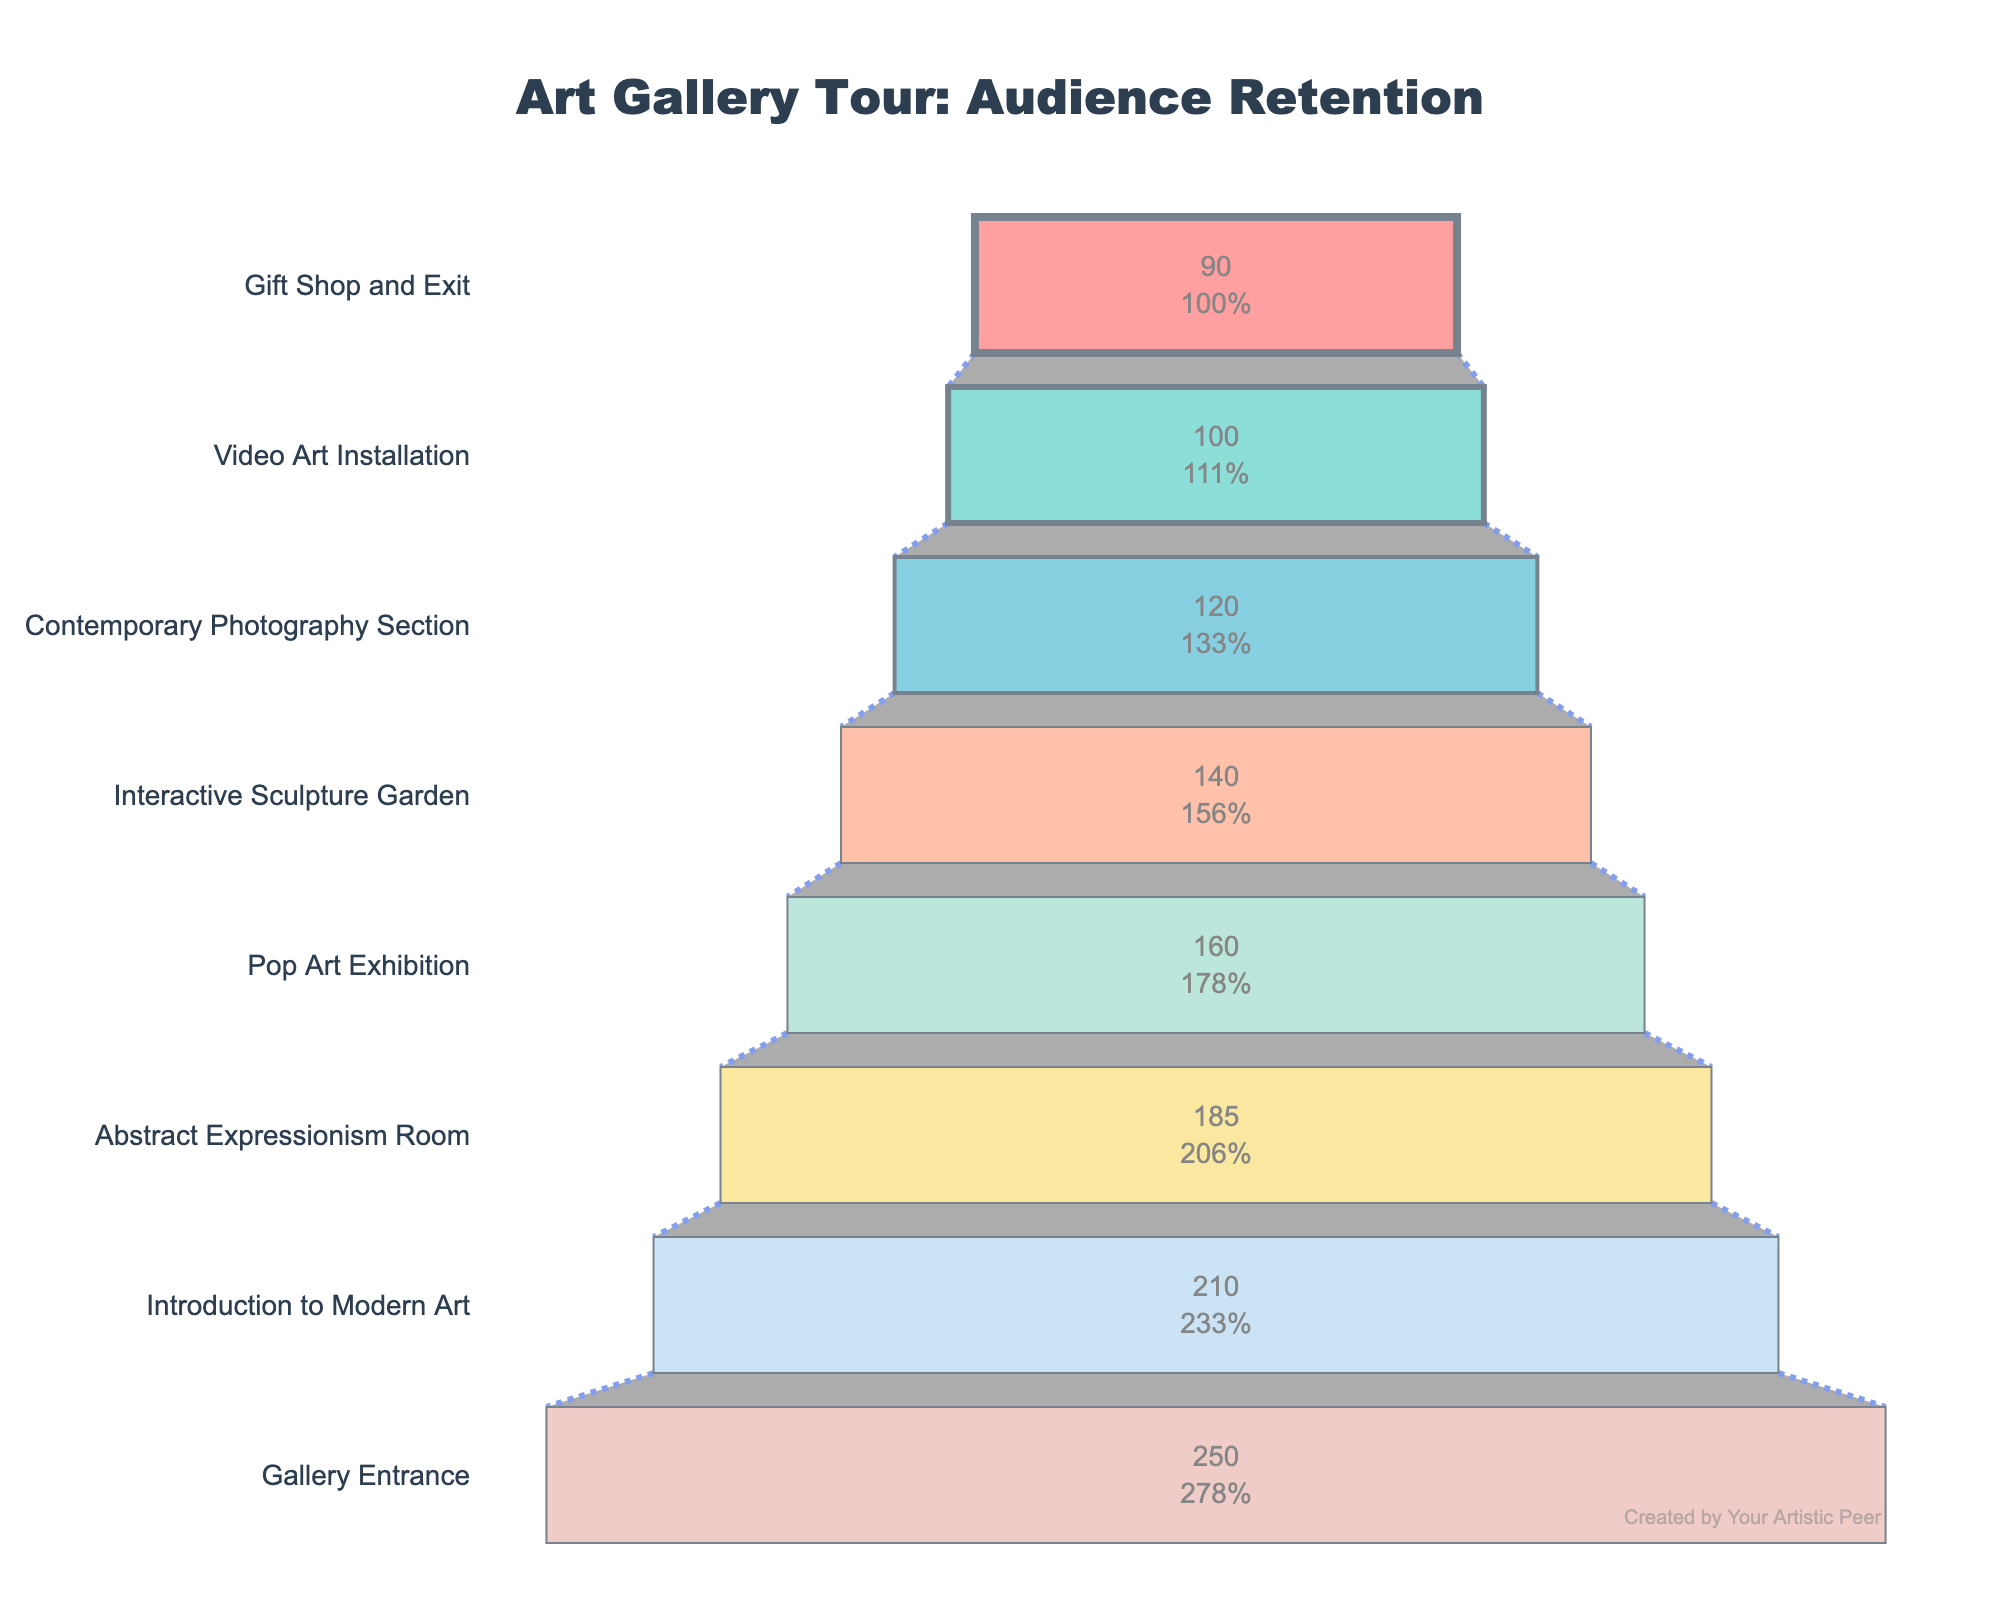what is the title of the chart? The title is prominently displayed at the top of the chart, which reads "Art Gallery Tour: Audience Retention".
Answer: Art Gallery Tour: Audience Retention Which segment had the highest number of visitors? The segment with the highest number of visitors is displayed at the top of the funnel, indicating the initial point of measurement.
Answer: Gallery Entrance What is the total drop-off in visitors from the entrance to the exit? We need to subtract the number of visitors at the "Gift Shop and Exit" segment from the "Gallery Entrance" segment. Hence, 250 (Entrance) - 90 (Exit) = 160.
Answer: 160 How many segments have fewer than 150 visitors? Examine each segment to determine if the number of visitors is less than 150. The segments with fewer than 150 visitors are "Contemporary Photography Section", "Video Art Installation", and "Gift Shop and Exit", totaling 3 segments.
Answer: 3 Which segment has the greatest retention from the previous segment in terms of raw numbers? By comparing the differences between consecutive segments, "Introduction to Modern Art" to "Abstract Expressionism Room" has the smallest drop-off of 25 visitors.
Answer: Abstract Expressionism Room What percentage of the initial visitors remained by the time they reached the "Video Art Installation"? Find the percentage by dividing visitors of "Video Art Installation" by "Gallery Entrance" and multiplying by 100. (100/250) * 100 = 40%
Answer: 40% Which segment had more visitors, the "Interactive Sculpture Garden" or the "Contemporary Photography Section"? Compare the number of visitors for each segment. The "Interactive Sculpture Garden" has 140 visitors, while the "Contemporary Photography Section" has 120. Hence, the "Interactive Sculpture Garden" had more visitors.
Answer: Interactive Sculpture Garden What is the average number of visitors per segment? Sum up all the visitors from each segment and divide by the number of segments. (250 + 210 + 185 + 160 + 140 + 120 + 100 + 90) / 8 = 156.25
Answer: 156.25 Which segment shows the largest percentage drop from the previous segment? To find this, calculate the percentage drop for each segment compared to its predecessor. The largest percentage drop is from "Video Art Installation" (100 visitors) to "Gift Shop and Exit" (90 visitors), which is 10/100 * 100 = 10%.
Answer: Gift Shop and Exit 